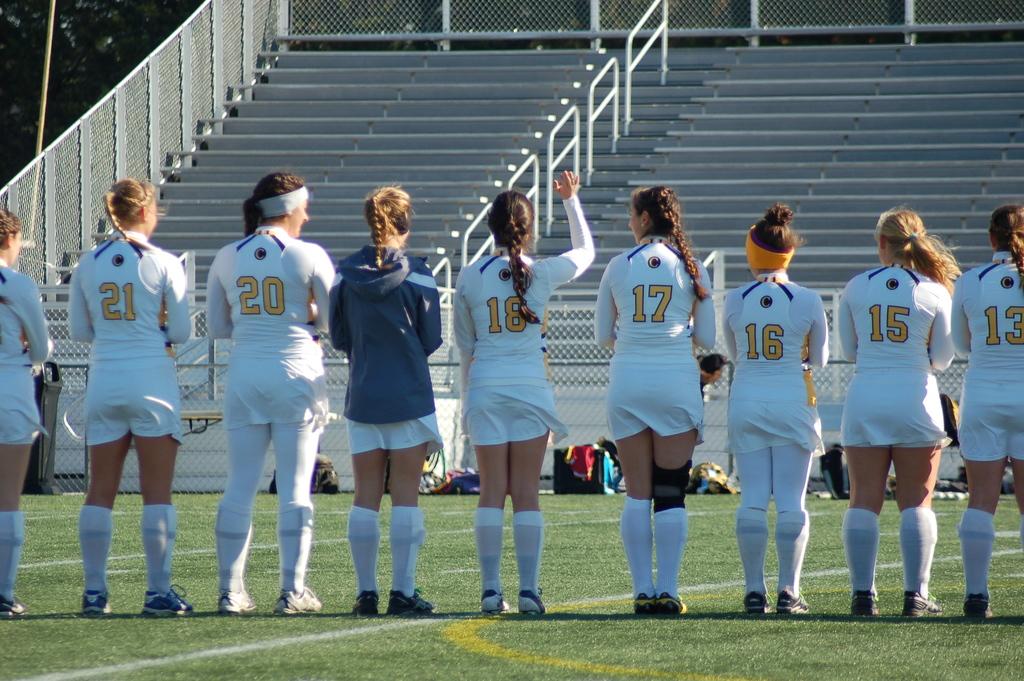What number is the girl on the right?
Keep it short and to the point. 13. 